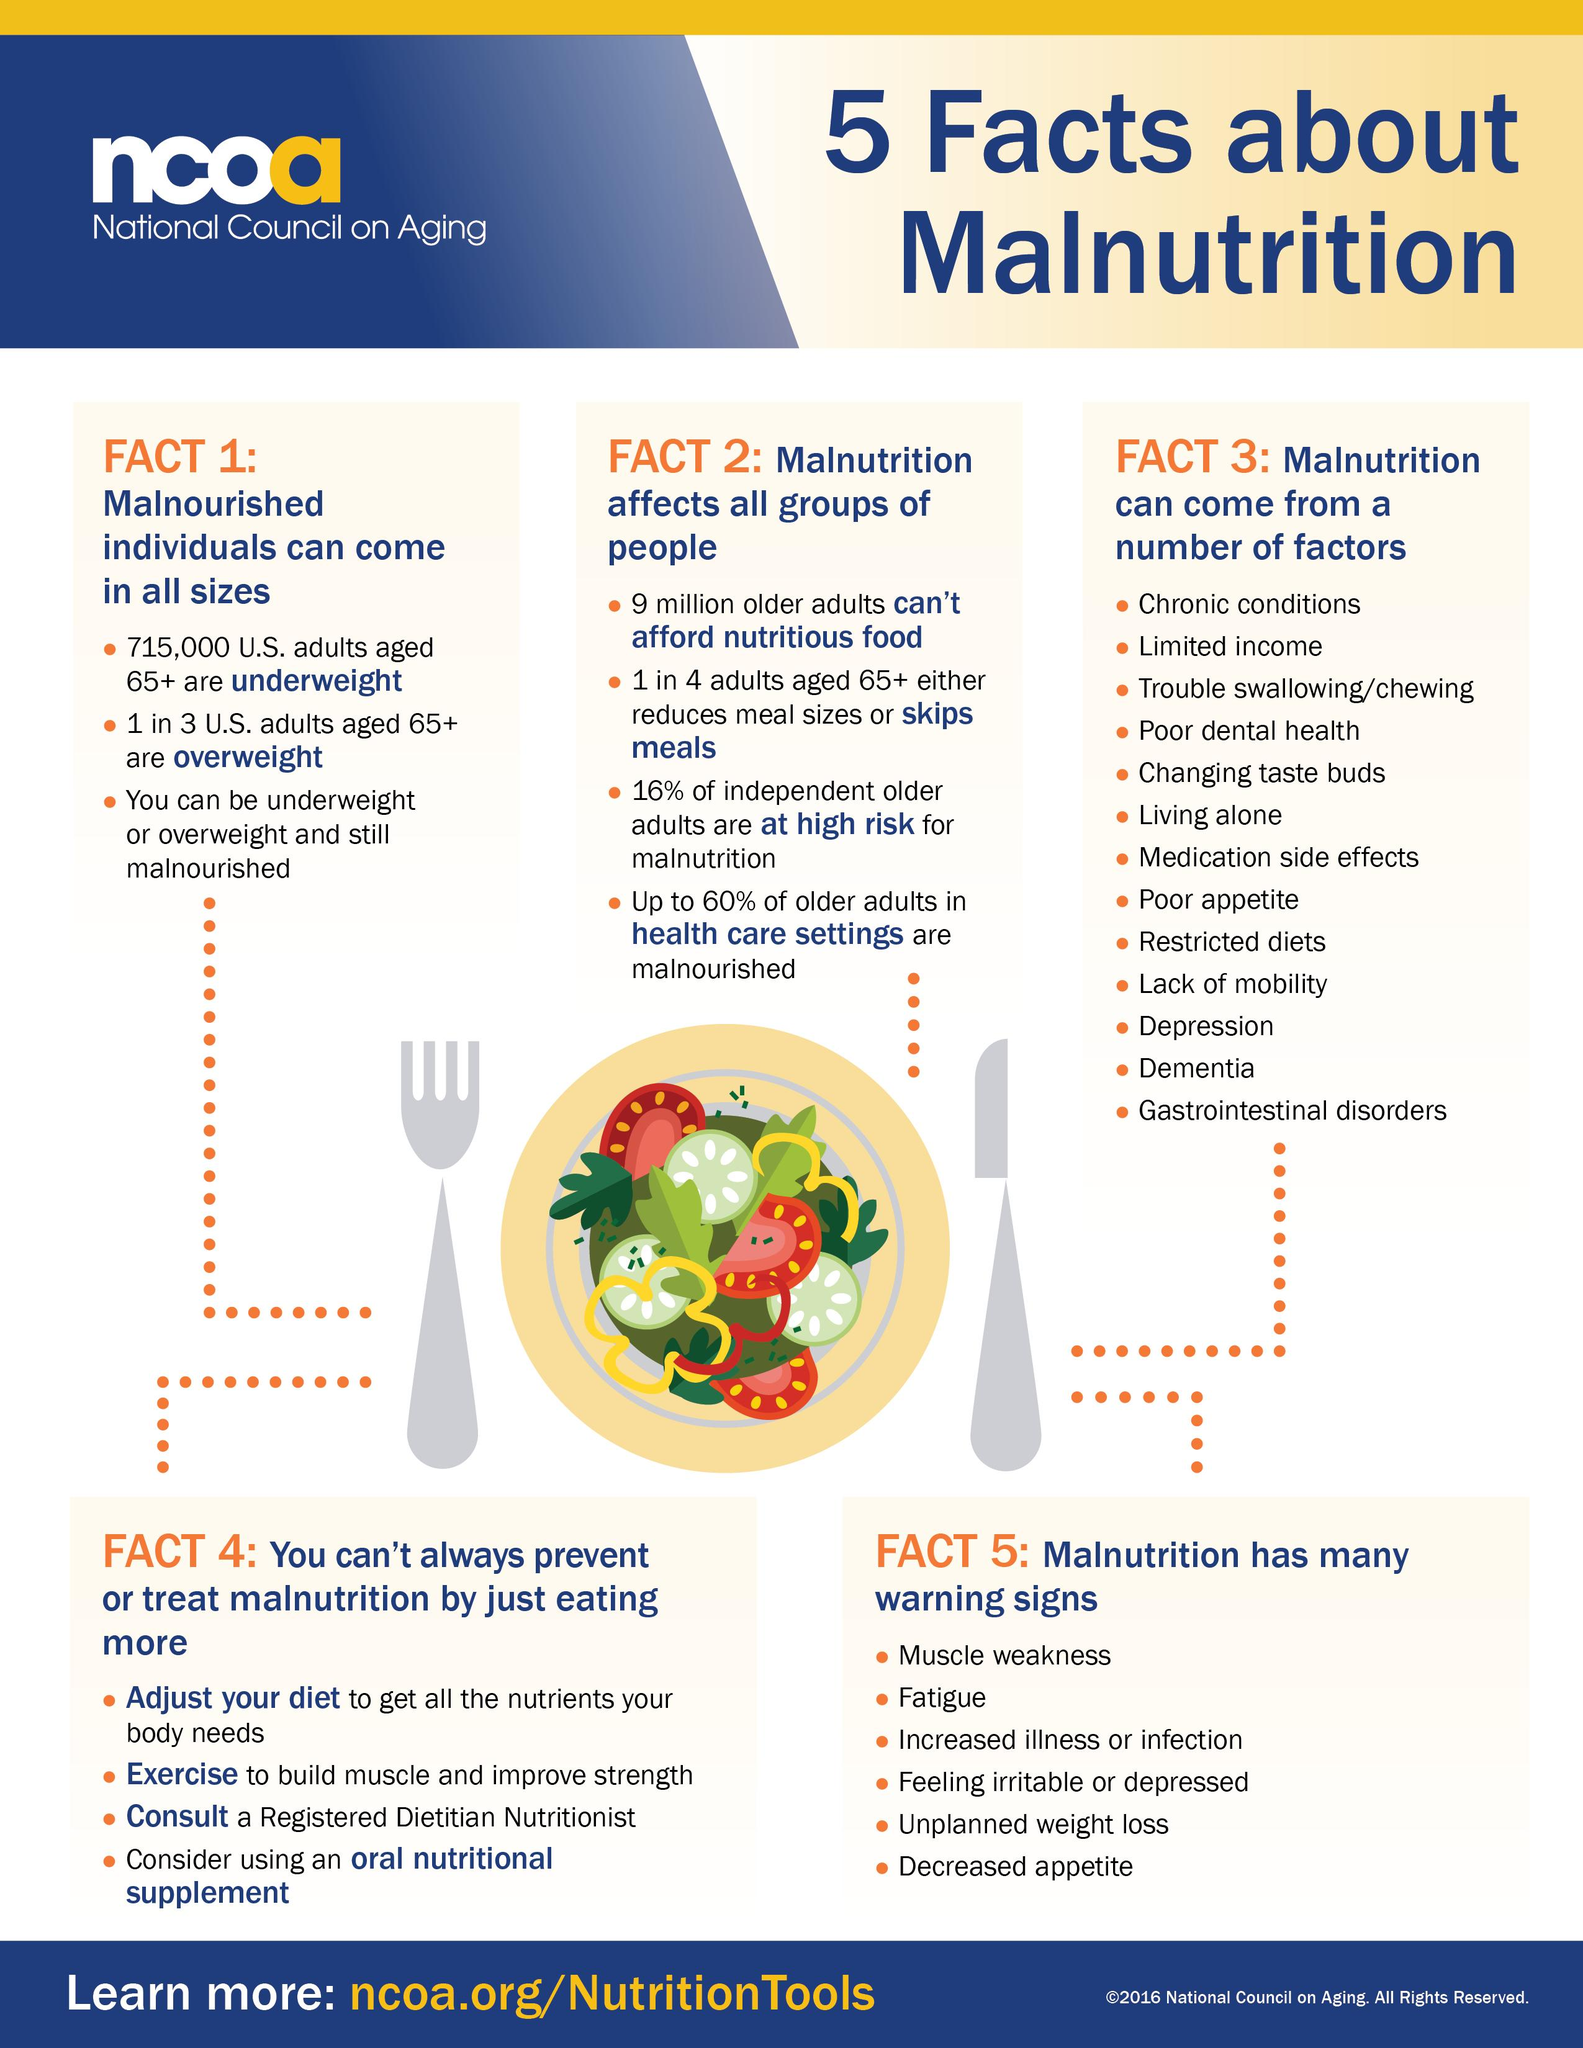Outline some significant characteristics in this image. According to data, about 65% of adults aged 65 and older in the US are not overweight. According to recent studies, only 40% of older adults in health care settings are not malnourished. This indicates a significant proportion of older adults are not receiving adequate nutrition, highlighting the need for improved care and interventions to address this issue. Approximately 715,000 senior citizens in the United States are underweight. 